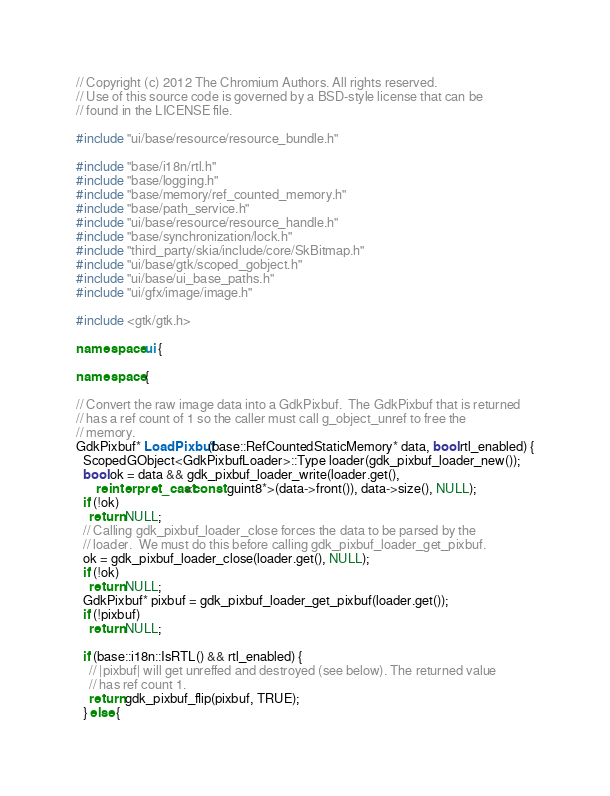Convert code to text. <code><loc_0><loc_0><loc_500><loc_500><_C++_>// Copyright (c) 2012 The Chromium Authors. All rights reserved.
// Use of this source code is governed by a BSD-style license that can be
// found in the LICENSE file.

#include "ui/base/resource/resource_bundle.h"

#include "base/i18n/rtl.h"
#include "base/logging.h"
#include "base/memory/ref_counted_memory.h"
#include "base/path_service.h"
#include "ui/base/resource/resource_handle.h"
#include "base/synchronization/lock.h"
#include "third_party/skia/include/core/SkBitmap.h"
#include "ui/base/gtk/scoped_gobject.h"
#include "ui/base/ui_base_paths.h"
#include "ui/gfx/image/image.h"

#include <gtk/gtk.h>

namespace ui {

namespace {

// Convert the raw image data into a GdkPixbuf.  The GdkPixbuf that is returned
// has a ref count of 1 so the caller must call g_object_unref to free the
// memory.
GdkPixbuf* LoadPixbuf(base::RefCountedStaticMemory* data, bool rtl_enabled) {
  ScopedGObject<GdkPixbufLoader>::Type loader(gdk_pixbuf_loader_new());
  bool ok = data && gdk_pixbuf_loader_write(loader.get(),
      reinterpret_cast<const guint8*>(data->front()), data->size(), NULL);
  if (!ok)
    return NULL;
  // Calling gdk_pixbuf_loader_close forces the data to be parsed by the
  // loader.  We must do this before calling gdk_pixbuf_loader_get_pixbuf.
  ok = gdk_pixbuf_loader_close(loader.get(), NULL);
  if (!ok)
    return NULL;
  GdkPixbuf* pixbuf = gdk_pixbuf_loader_get_pixbuf(loader.get());
  if (!pixbuf)
    return NULL;

  if (base::i18n::IsRTL() && rtl_enabled) {
    // |pixbuf| will get unreffed and destroyed (see below). The returned value
    // has ref count 1.
    return gdk_pixbuf_flip(pixbuf, TRUE);
  } else {</code> 